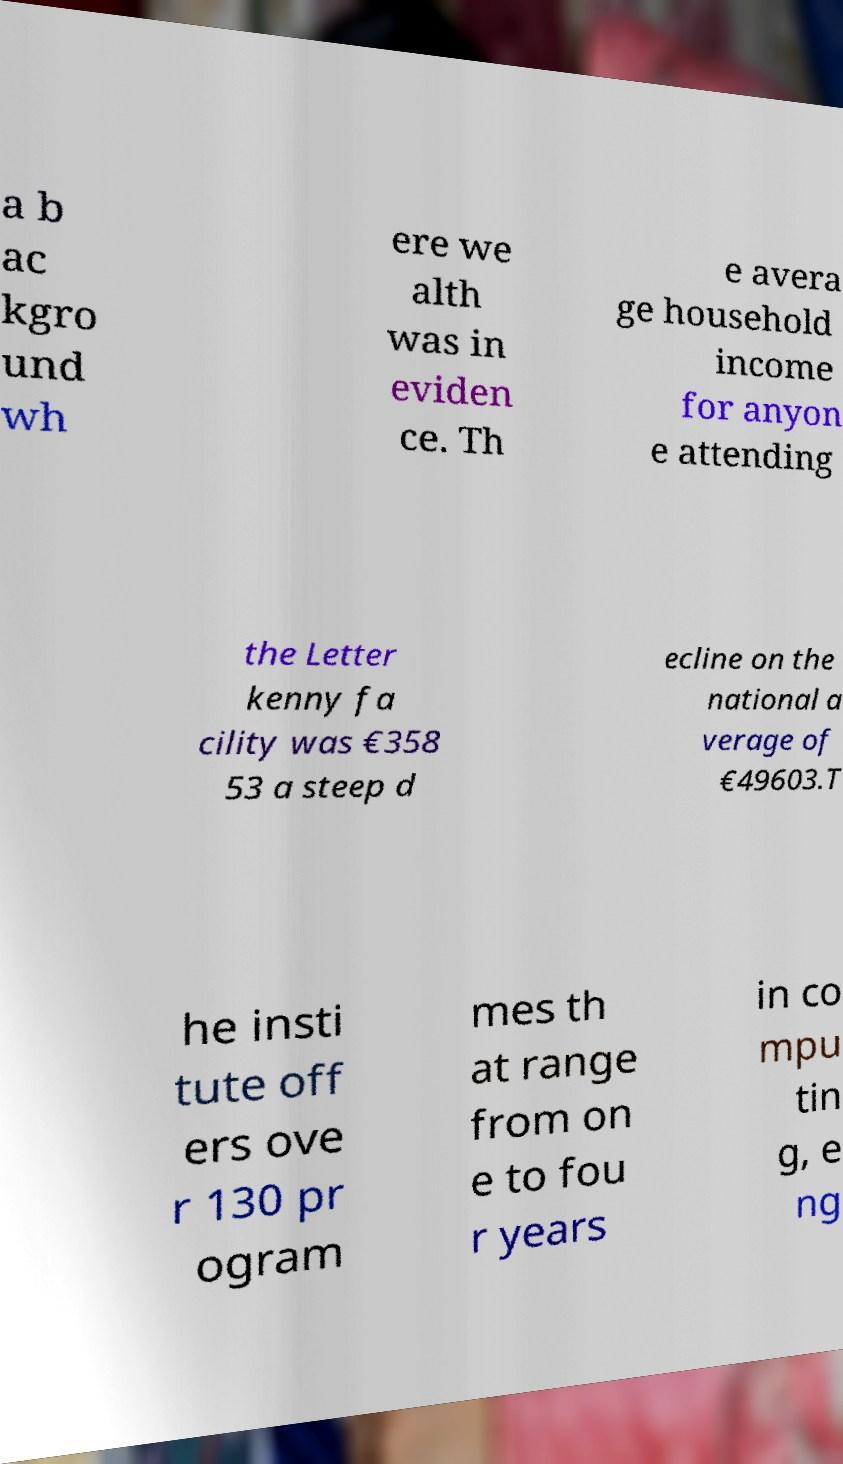Please read and relay the text visible in this image. What does it say? a b ac kgro und wh ere we alth was in eviden ce. Th e avera ge household income for anyon e attending the Letter kenny fa cility was €358 53 a steep d ecline on the national a verage of €49603.T he insti tute off ers ove r 130 pr ogram mes th at range from on e to fou r years in co mpu tin g, e ng 